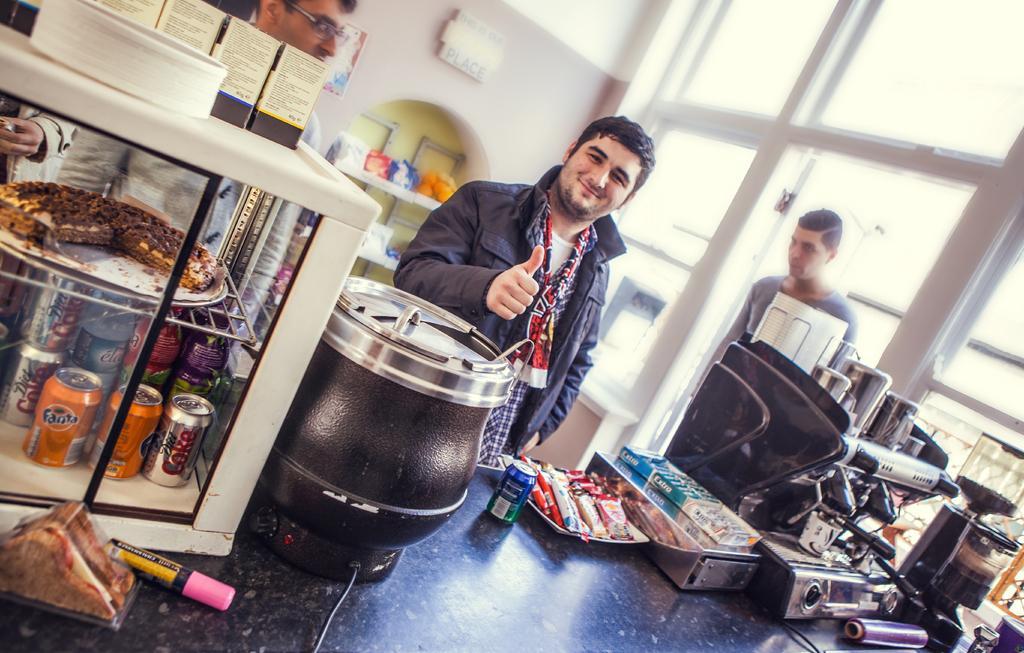Describe this image in one or two sentences. In this picture there is a table at the bottom side of the image and there are vending machines on it and cool drinks, there are people in front of it and there are windows on the right side of the image. 